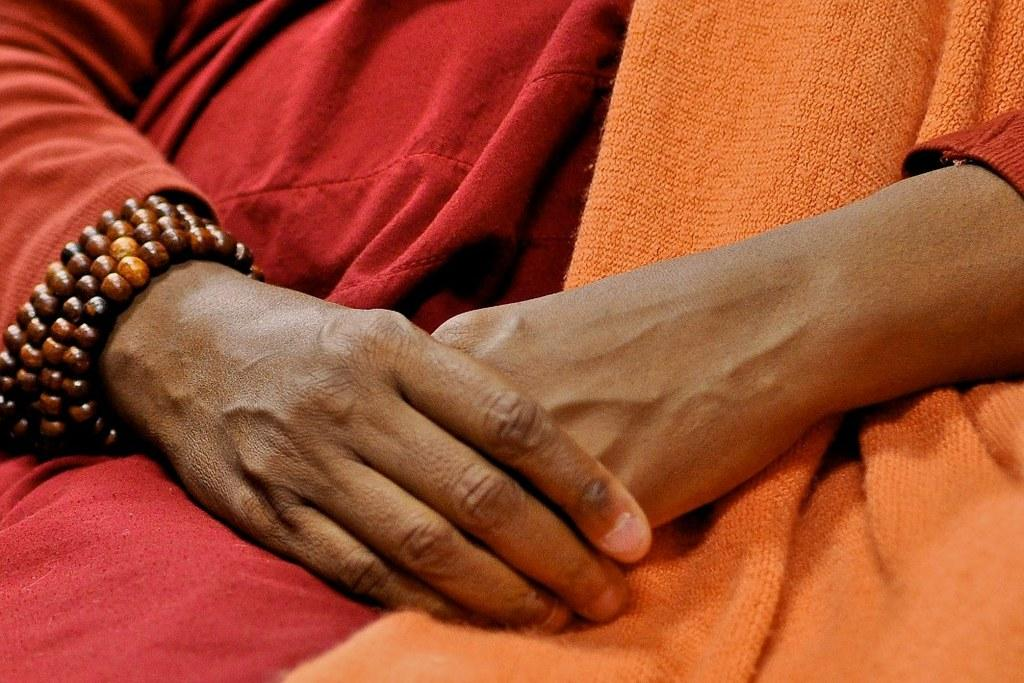What body part is visible in the image? There are hands visible in the image. What type of cloth can be seen in the image? There is a red and orange cloth in the image. What is the color and nature of the object in the image? There is a brown color thing in the image. What activity are the hands engaged in with the apples in the image? There are no apples present in the image, so no such activity can be observed. Can you describe the man in the image? There is no man present in the image; only hands and a red and orange cloth are visible. 